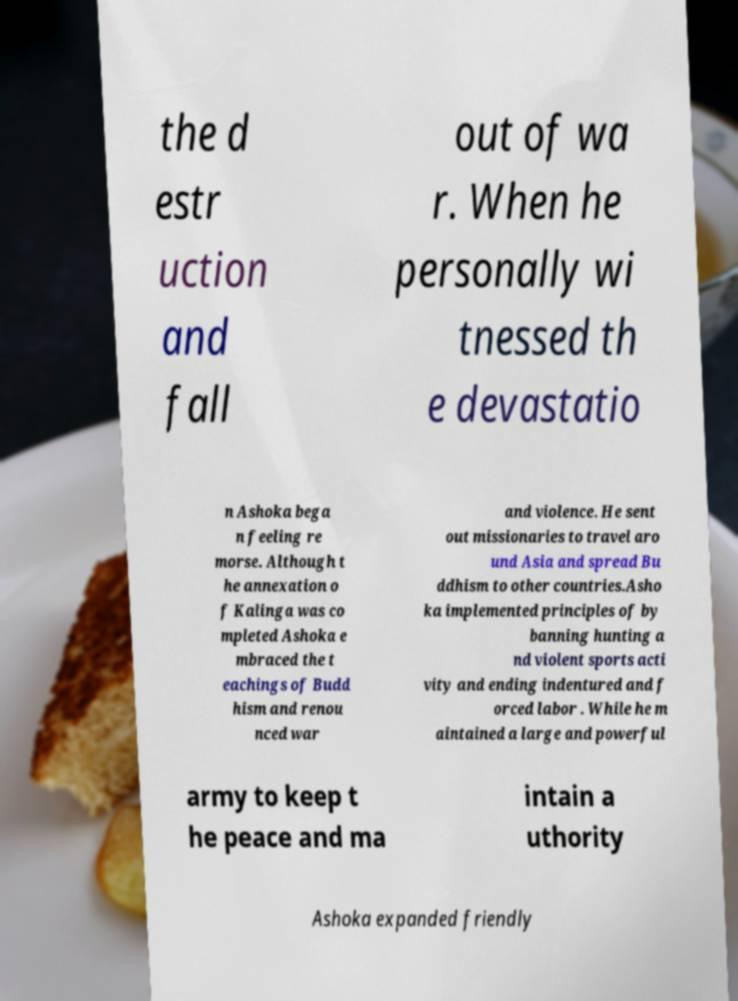There's text embedded in this image that I need extracted. Can you transcribe it verbatim? the d estr uction and fall out of wa r. When he personally wi tnessed th e devastatio n Ashoka bega n feeling re morse. Although t he annexation o f Kalinga was co mpleted Ashoka e mbraced the t eachings of Budd hism and renou nced war and violence. He sent out missionaries to travel aro und Asia and spread Bu ddhism to other countries.Asho ka implemented principles of by banning hunting a nd violent sports acti vity and ending indentured and f orced labor . While he m aintained a large and powerful army to keep t he peace and ma intain a uthority Ashoka expanded friendly 